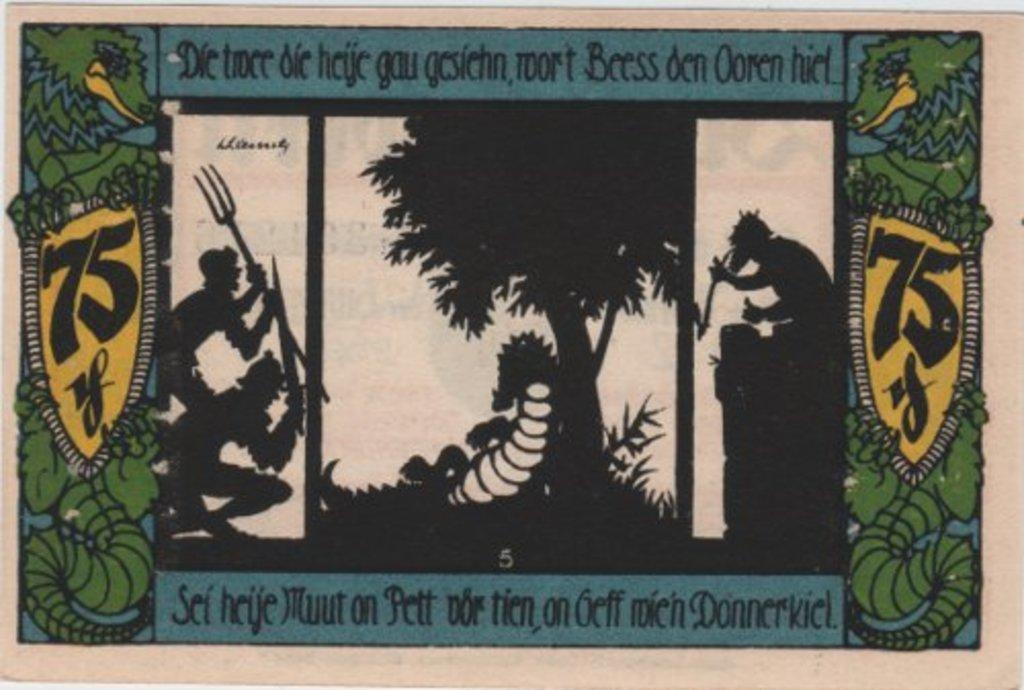Could you give a brief overview of what you see in this image? This is a poster. On this poster we can see three persons are holding weapons. There is a tree and text written on it. 